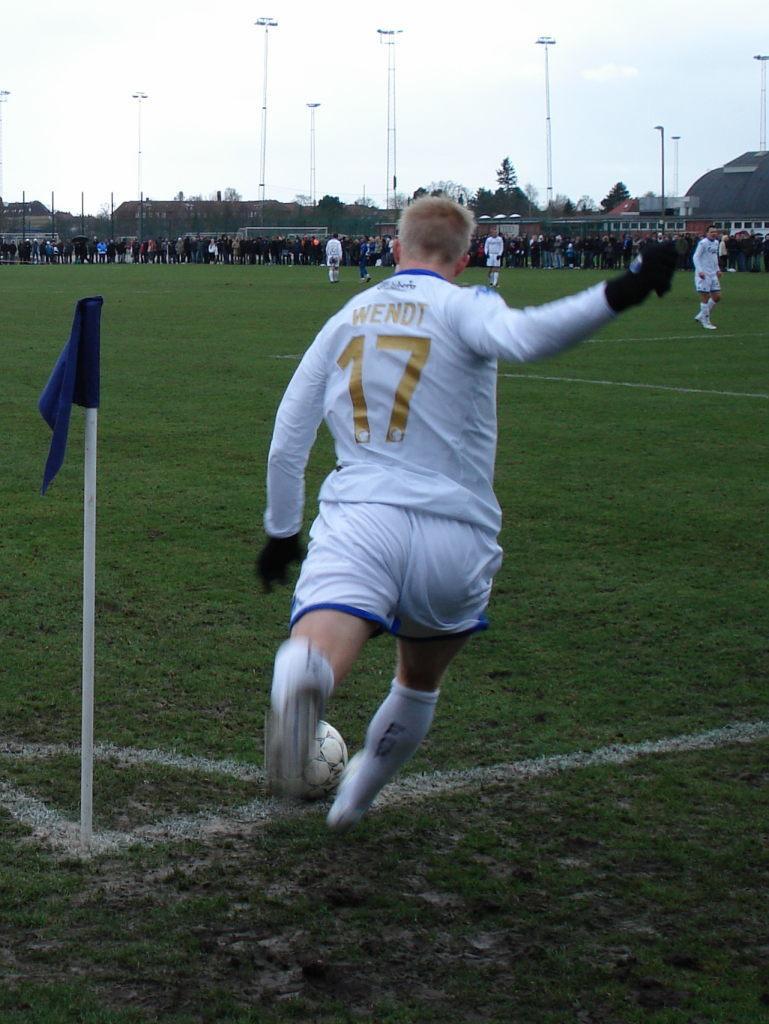Please provide a concise description of this image. In this picture inside of the ground. There is a group of people. They are standing. In the center person kicked the ball. We can see in background poles,sky and ground. 